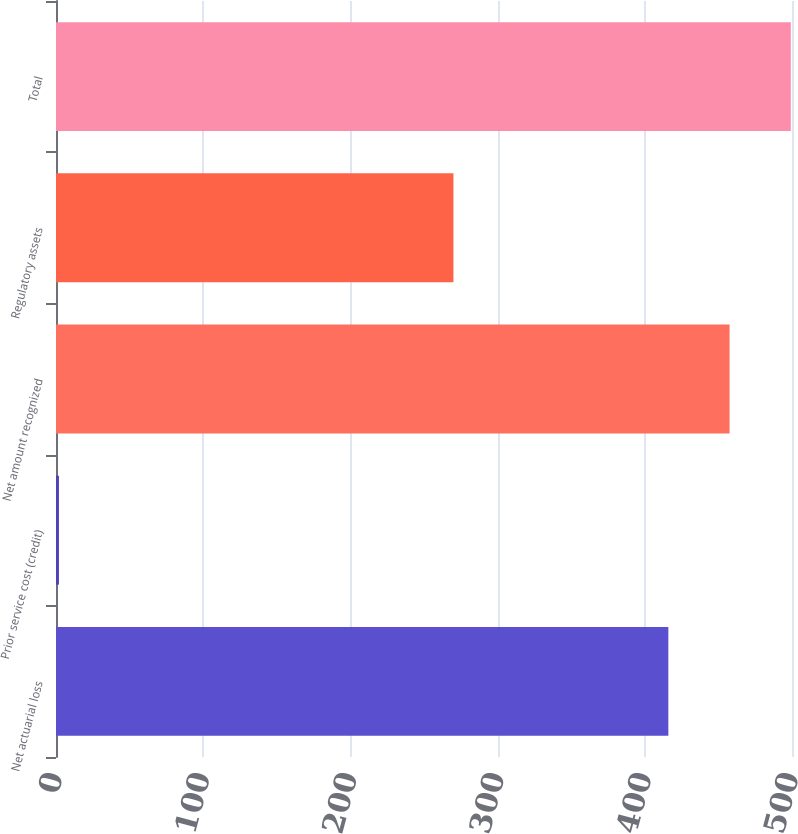<chart> <loc_0><loc_0><loc_500><loc_500><bar_chart><fcel>Net actuarial loss<fcel>Prior service cost (credit)<fcel>Net amount recognized<fcel>Regulatory assets<fcel>Total<nl><fcel>416<fcel>2<fcel>457.6<fcel>270<fcel>499.2<nl></chart> 